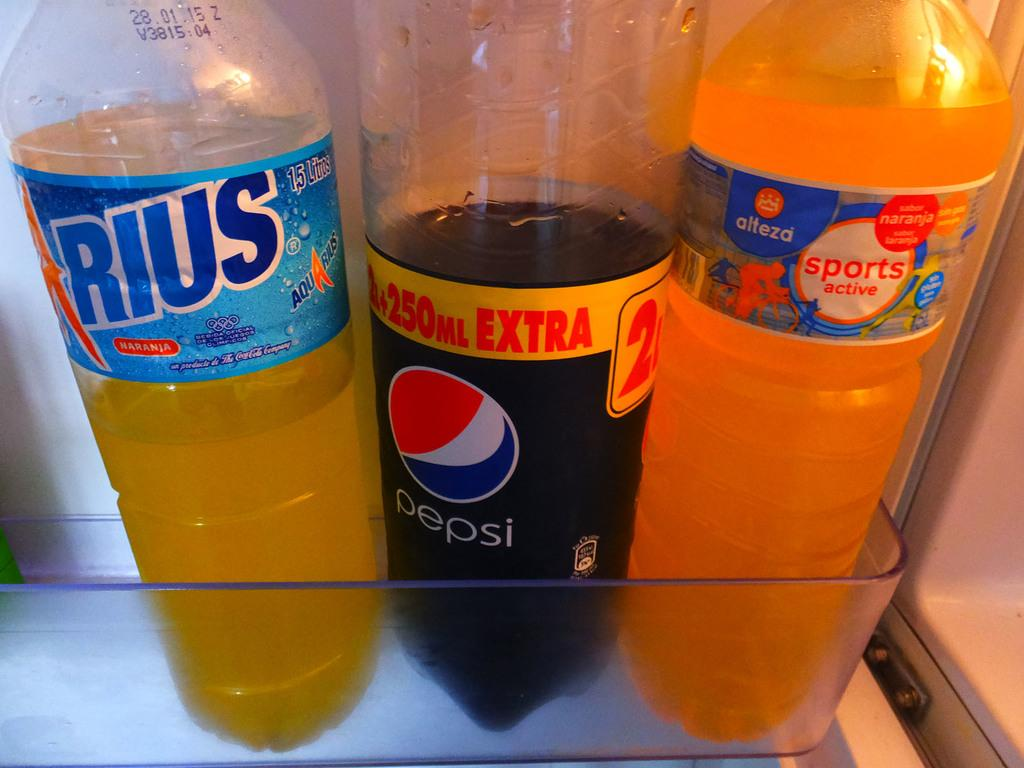<image>
Share a concise interpretation of the image provided. A half empty bottle of Pepsi is between to other drinks. 